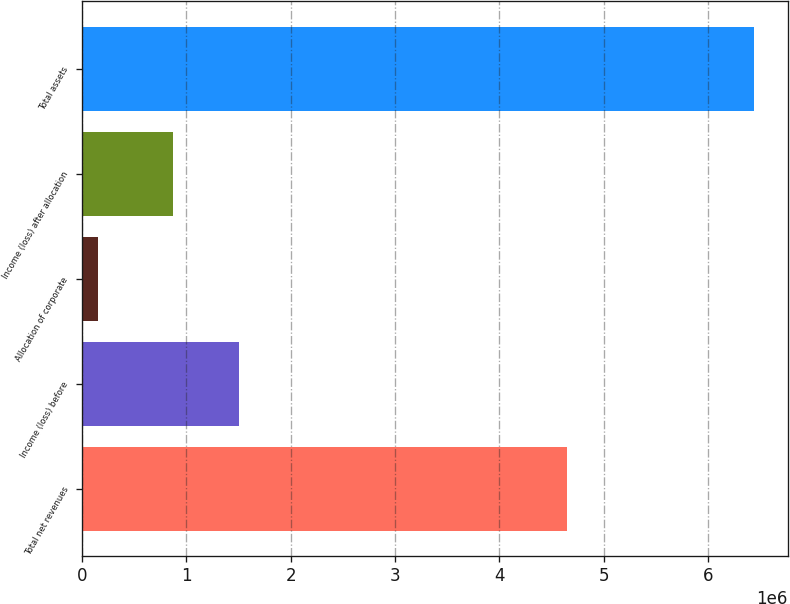Convert chart to OTSL. <chart><loc_0><loc_0><loc_500><loc_500><bar_chart><fcel>Total net revenues<fcel>Income (loss) before<fcel>Allocation of corporate<fcel>Income (loss) after allocation<fcel>Total assets<nl><fcel>4.64501e+06<fcel>1.50443e+06<fcel>154843<fcel>875891<fcel>6.4402e+06<nl></chart> 